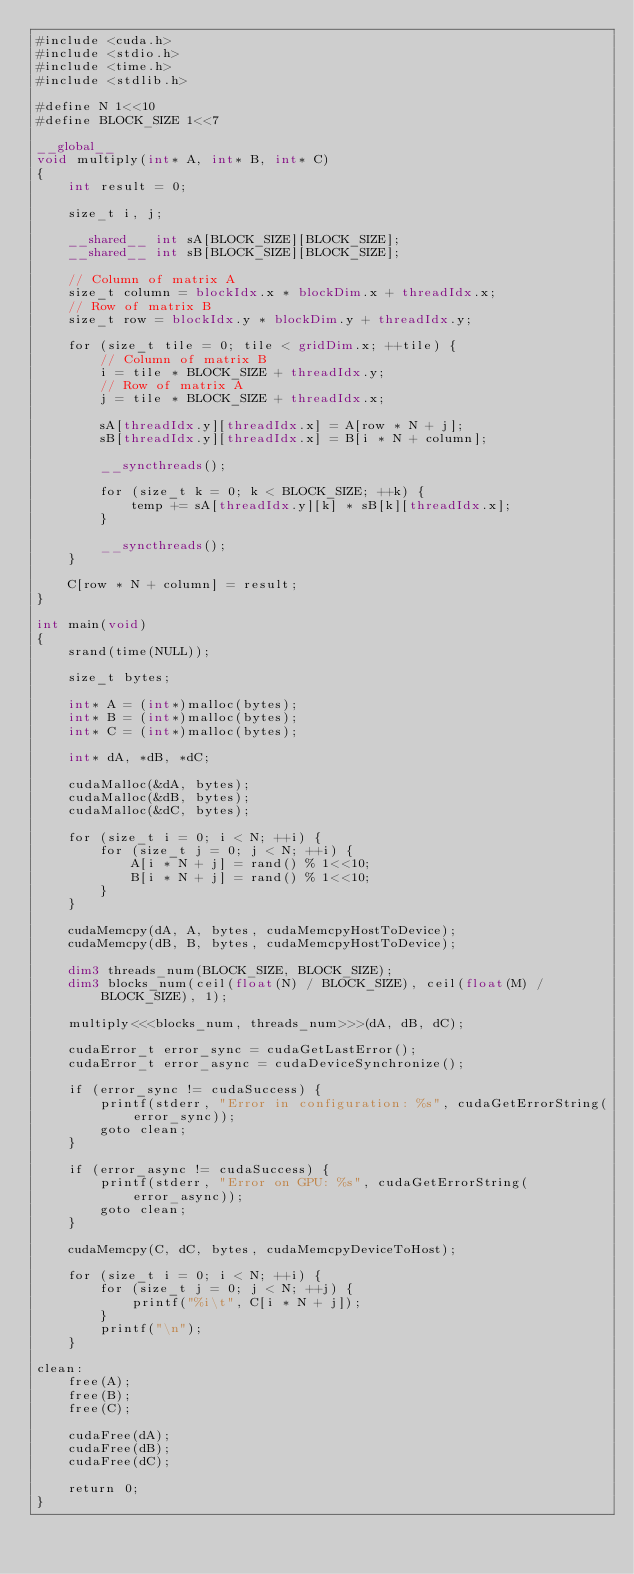Convert code to text. <code><loc_0><loc_0><loc_500><loc_500><_Cuda_>#include <cuda.h>
#include <stdio.h>
#include <time.h>
#include <stdlib.h>

#define N 1<<10
#define BLOCK_SIZE 1<<7

__global__
void multiply(int* A, int* B, int* C)
{
    int result = 0;

    size_t i, j;

    __shared__ int sA[BLOCK_SIZE][BLOCK_SIZE];
    __shared__ int sB[BLOCK_SIZE][BLOCK_SIZE];

    // Column of matrix A
    size_t column = blockIdx.x * blockDim.x + threadIdx.x;
    // Row of matrix B
    size_t row = blockIdx.y * blockDim.y + threadIdx.y;

    for (size_t tile = 0; tile < gridDim.x; ++tile) {
        // Column of matrix B
        i = tile * BLOCK_SIZE + threadIdx.y;
        // Row of matrix A
        j = tile * BLOCK_SIZE + threadIdx.x;

        sA[threadIdx.y][threadIdx.x] = A[row * N + j];
        sB[threadIdx.y][threadIdx.x] = B[i * N + column];

        __syncthreads();

        for (size_t k = 0; k < BLOCK_SIZE; ++k) {
            temp += sA[threadIdx.y][k] * sB[k][threadIdx.x];
        }

        __syncthreads();
    }

    C[row * N + column] = result;
}

int main(void)
{
    srand(time(NULL));

    size_t bytes;

    int* A = (int*)malloc(bytes);
    int* B = (int*)malloc(bytes);
    int* C = (int*)malloc(bytes);

    int* dA, *dB, *dC;

    cudaMalloc(&dA, bytes);
    cudaMalloc(&dB, bytes);
    cudaMalloc(&dC, bytes);

    for (size_t i = 0; i < N; ++i) {
        for (size_t j = 0; j < N; ++i) {
            A[i * N + j] = rand() % 1<<10;
            B[i * N + j] = rand() % 1<<10;
        }
    }

    cudaMemcpy(dA, A, bytes, cudaMemcpyHostToDevice);
    cudaMemcpy(dB, B, bytes, cudaMemcpyHostToDevice);

    dim3 threads_num(BLOCK_SIZE, BLOCK_SIZE);
    dim3 blocks_num(ceil(float(N) / BLOCK_SIZE), ceil(float(M) / BLOCK_SIZE), 1);

    multiply<<<blocks_num, threads_num>>>(dA, dB, dC);

    cudaError_t error_sync = cudaGetLastError();
    cudaError_t error_async = cudaDeviceSynchronize();

    if (error_sync != cudaSuccess) {
        printf(stderr, "Error in configuration: %s", cudaGetErrorString(error_sync));
        goto clean;
    }

    if (error_async != cudaSuccess) {
        printf(stderr, "Error on GPU: %s", cudaGetErrorString(error_async));
        goto clean;
    }

    cudaMemcpy(C, dC, bytes, cudaMemcpyDeviceToHost);

    for (size_t i = 0; i < N; ++i) {
        for (size_t j = 0; j < N; ++j) {
            printf("%i\t", C[i * N + j]);
        }
        printf("\n");
    }

clean:
    free(A);
    free(B);
    free(C);

    cudaFree(dA);
    cudaFree(dB);
    cudaFree(dC);

    return 0;
}
</code> 